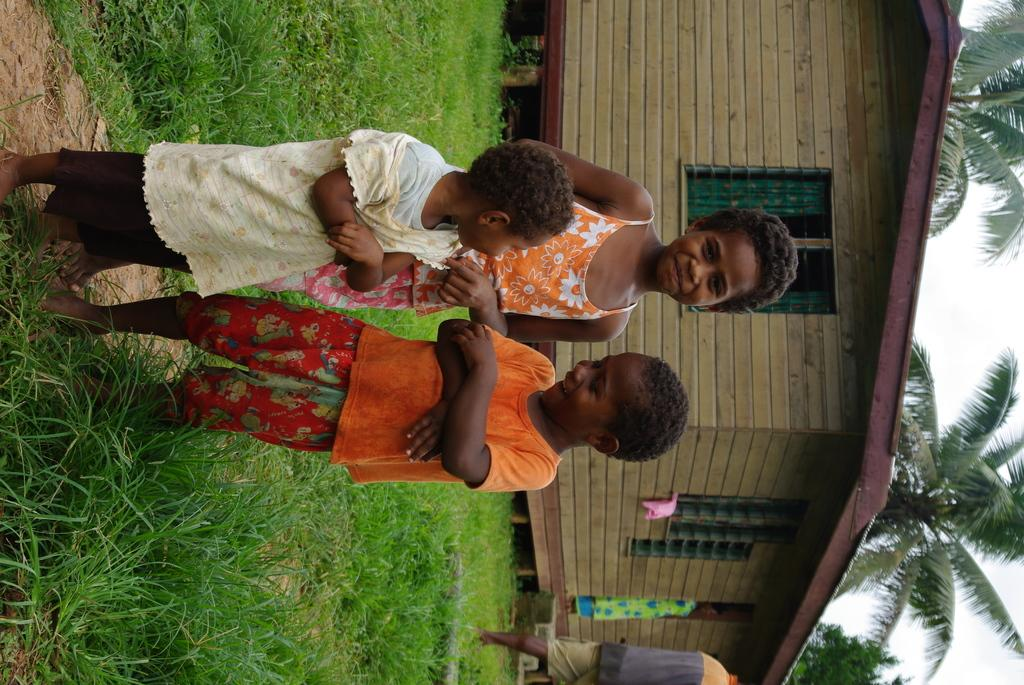How many kids are present in the image? There are three kids standing in the image. What is at the bottom of the image? There is grass at the bottom of the image. What can be seen in the background of the image? There is a house and trees in the background of the image. What is visible in the sky in the image? The sky is visible in the image. What month is it in the image? The month cannot be determined from the image, as there is no information about the time of year. Can you tell me what type of structure the grandfather is sitting on in the image? There is no grandfather or any structure for him to sit on in the image. 